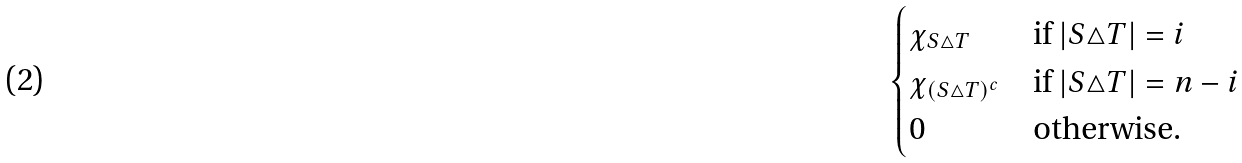<formula> <loc_0><loc_0><loc_500><loc_500>\begin{cases} \chi _ { S \triangle T } & \text {if } | S \triangle T | = i \\ \chi _ { ( S \triangle T ) ^ { c } } & \text {if } | S \triangle T | = n - i \\ 0 & \text {otherwise.} \end{cases}</formula> 